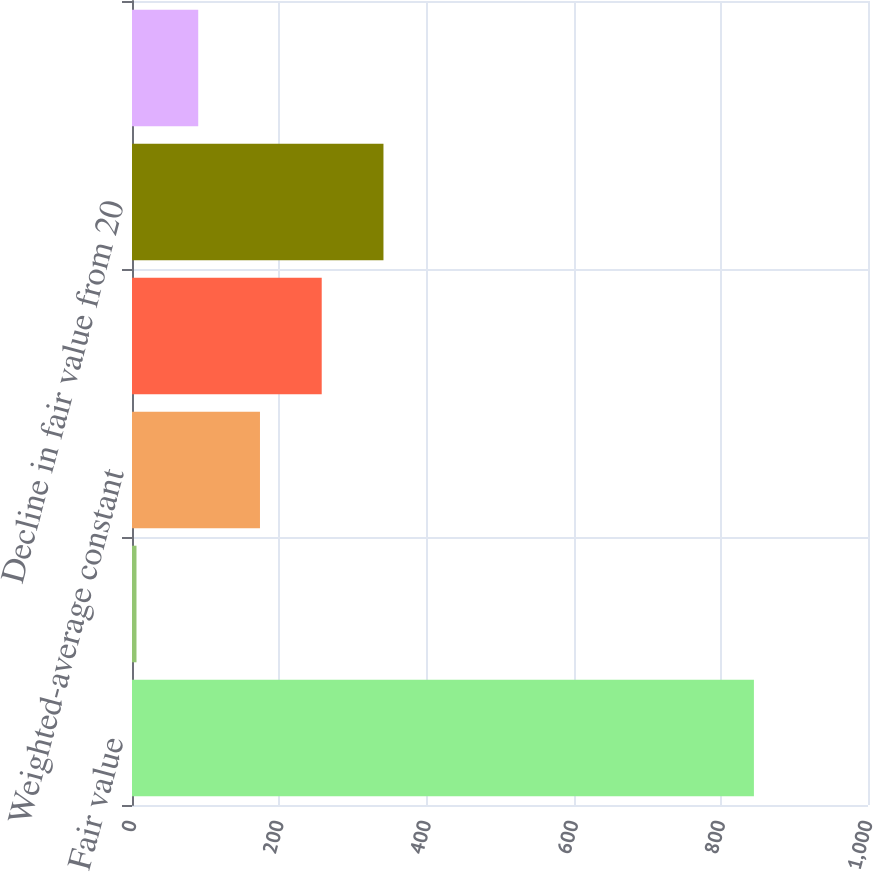Convert chart to OTSL. <chart><loc_0><loc_0><loc_500><loc_500><bar_chart><fcel>Fair value<fcel>Weighted-average life (years)<fcel>Weighted-average constant<fcel>Decline in fair value from 10<fcel>Decline in fair value from 20<fcel>Weighted-average option<nl><fcel>845<fcel>6.1<fcel>173.88<fcel>257.77<fcel>341.66<fcel>89.99<nl></chart> 